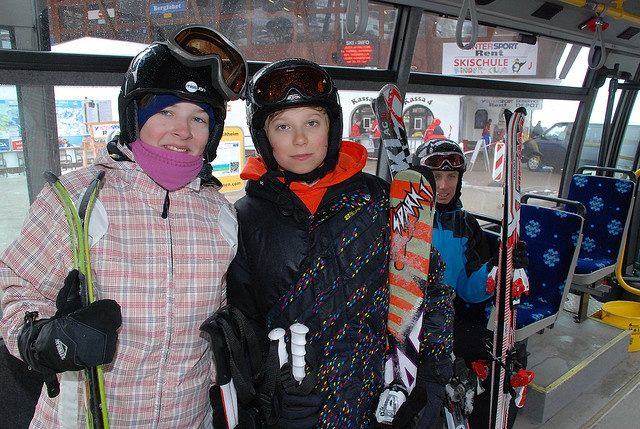Describe the objects in this image and their specific colors. I can see people in gray, darkgray, black, and lightgray tones, people in gray, black, brown, and navy tones, skis in gray, black, darkgray, and brown tones, people in gray, black, blue, and navy tones, and skis in gray, black, darkgray, and brown tones in this image. 